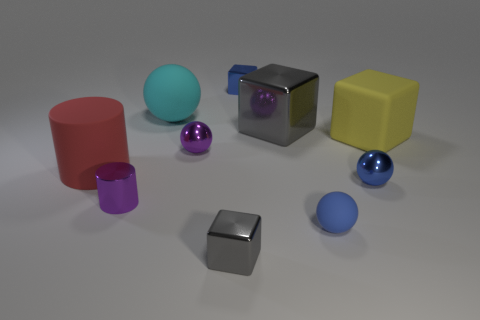How many other large yellow things have the same shape as the yellow rubber thing? 0 